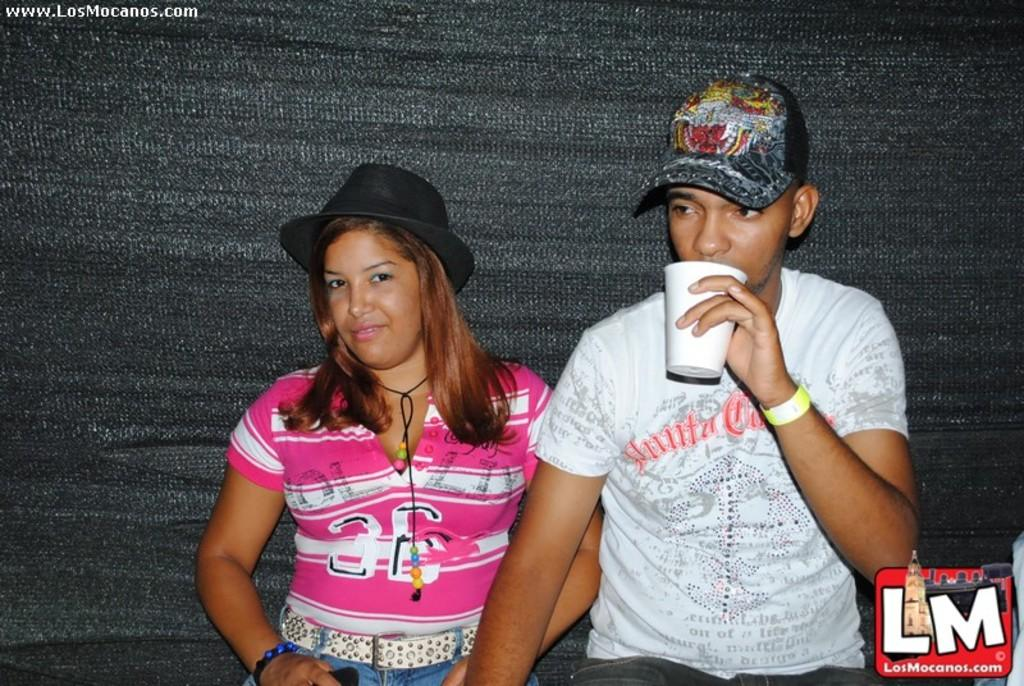Who can be seen in the foreground of the picture? There is a man and a woman sitting in the foreground of the picture. What are the man and woman wearing on their heads? The man and woman are wearing caps. What is located on the right side of the image? There is a logo on the right side of the image. What material appears to make up the background of the image? The background appears to be made of cloth. How much wealth does the man in the image possess? There is no information about the man's wealth in the image. What class does the woman in the image belong to? There is no information about the woman's class in the image. 